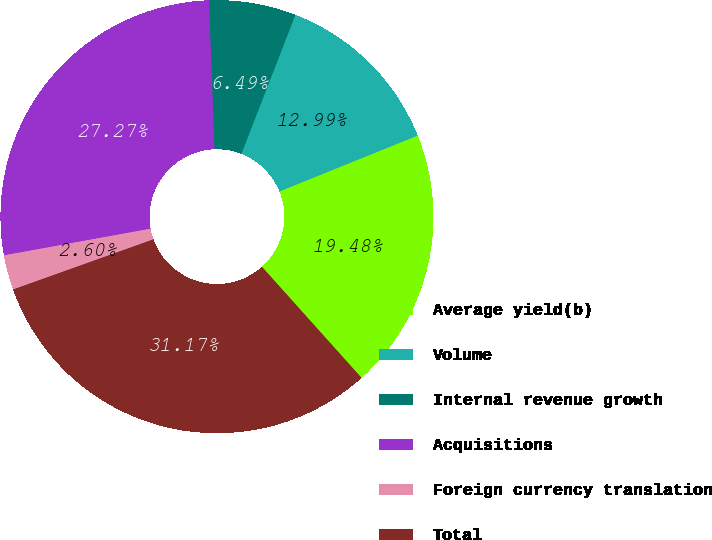Convert chart to OTSL. <chart><loc_0><loc_0><loc_500><loc_500><pie_chart><fcel>Average yield(b)<fcel>Volume<fcel>Internal revenue growth<fcel>Acquisitions<fcel>Foreign currency translation<fcel>Total<nl><fcel>19.48%<fcel>12.99%<fcel>6.49%<fcel>27.27%<fcel>2.6%<fcel>31.17%<nl></chart> 